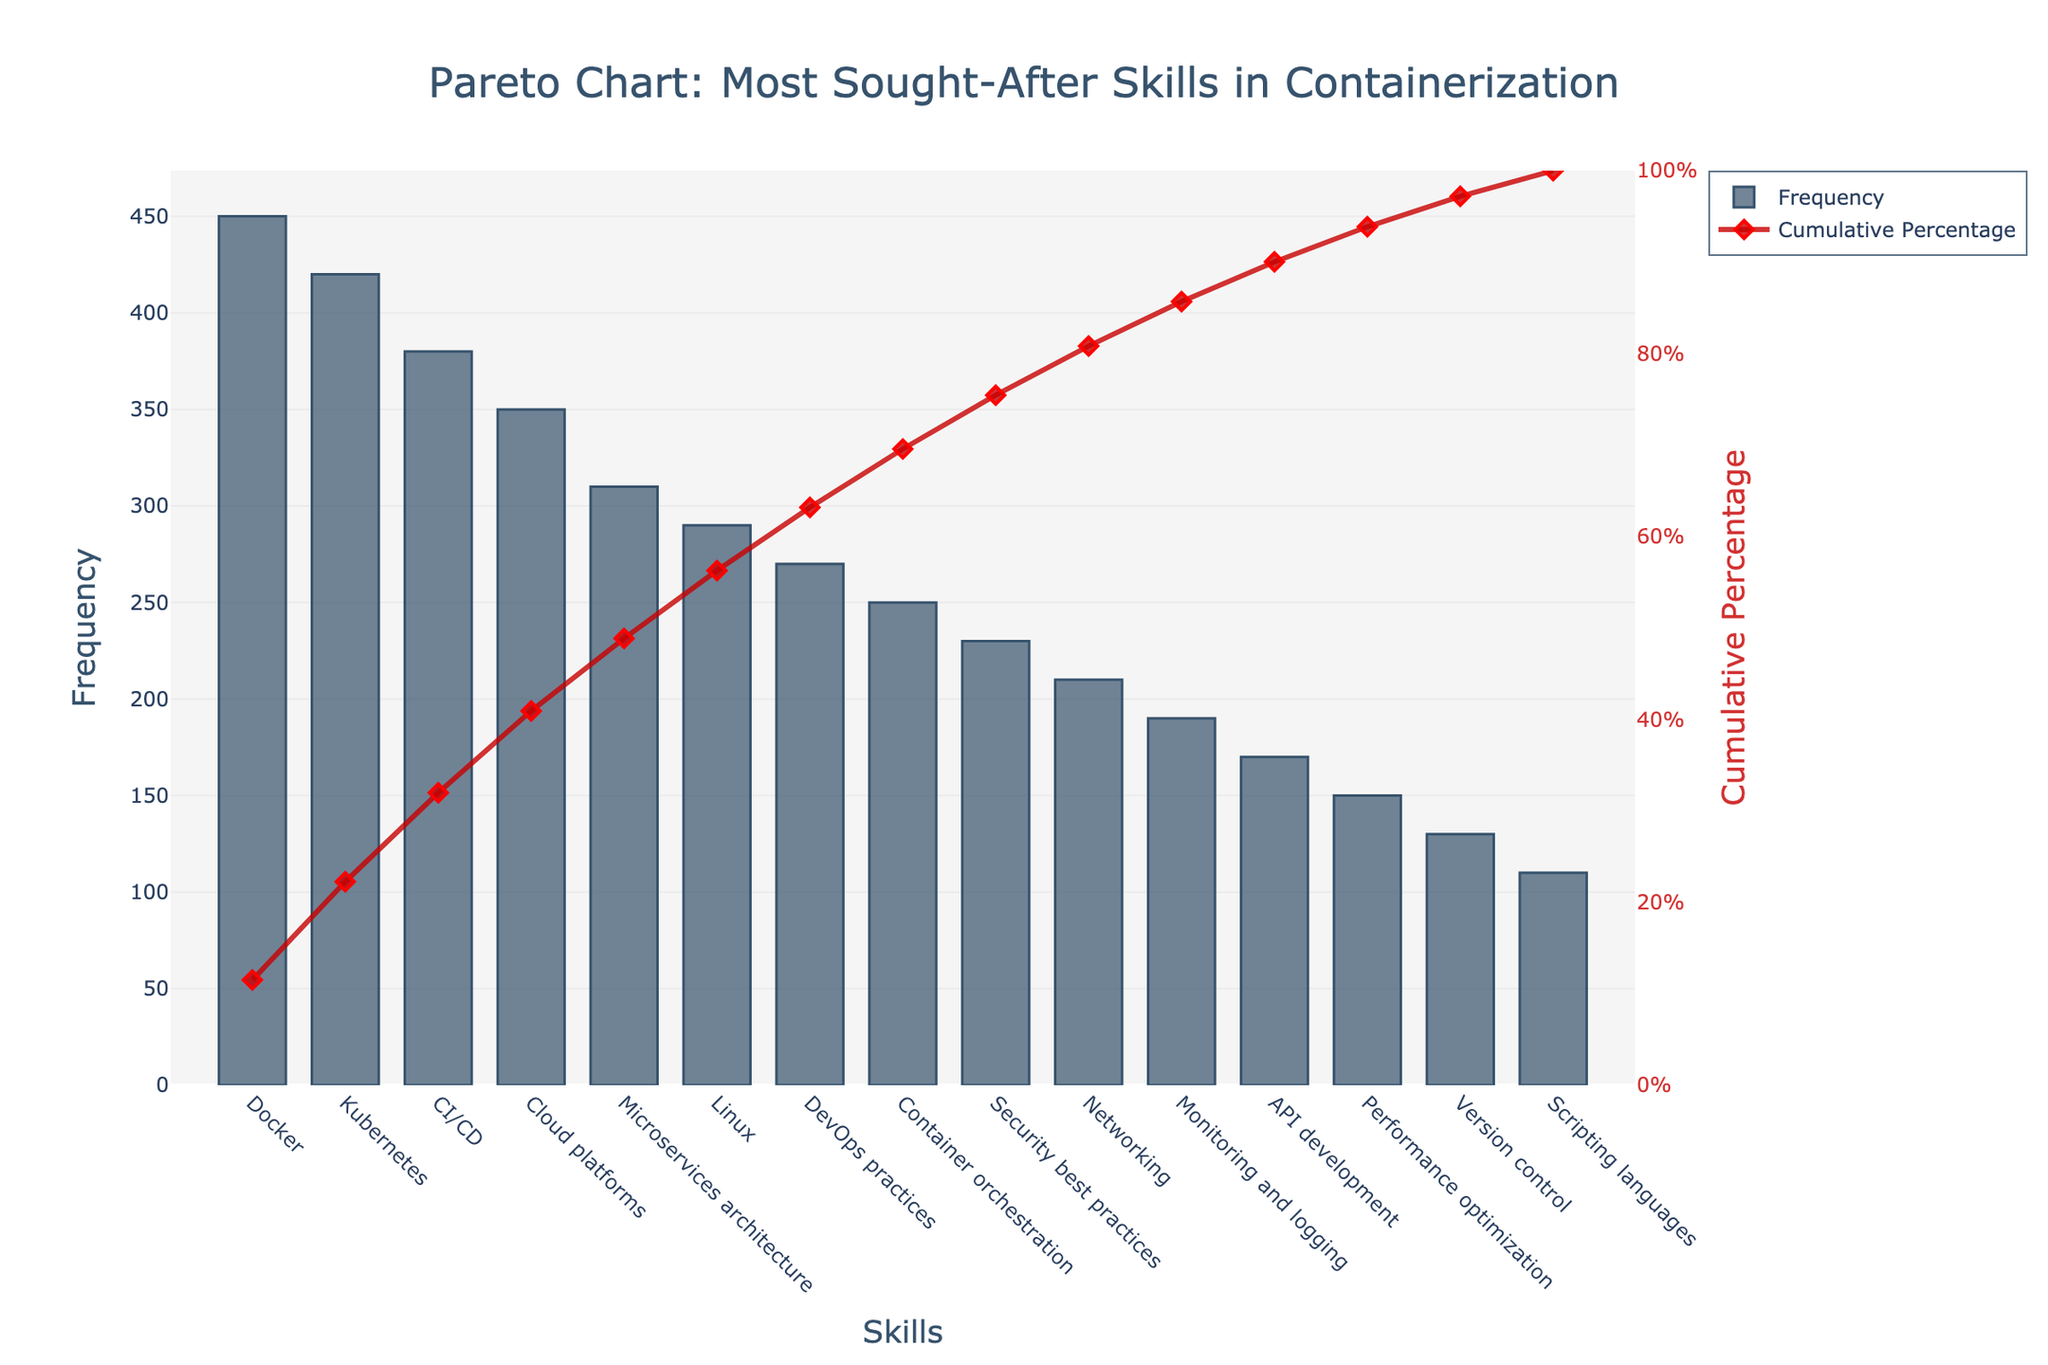What is the skill with the highest demand in the job postings? Looking at the Pareto chart, the skill with the highest frequency bar is at the leftmost of the chart. Its label is "Docker".
Answer: Docker What is the cumulative percentage for Kubernetes? On the Pareto chart, the cumulative percentage line intersects with the Kubernetes bar, which corresponds to a point slightly lower than 40%.
Answer: Slightly lower than 40% How many skills have a frequency over 300? Observing the bars in the Pareto chart, the skills above 300 frequency are Docker, Kubernetes, CI/CD, and Cloud platforms. There are four such skills.
Answer: 4 Which skill has the lowest demand in job postings? The rightmost bar in the Pareto chart has the label "Scripting languages" with the lowest bar height, indicating it's the skill with the lowest demand.
Answer: Scripting languages How many skills make up approximately 80% of the cumulative percentage? Follow the cumulative percentage line until it reaches close to 80%, which touches at the "CI/CD" skill as the last contributing skill. Counting from Docker to CI/CD, there are four skills.
Answer: 4 What is the combined frequency of Cloud platforms and Microservices architecture? The frequency for Cloud platforms is 350 and for Microservices architecture is 310. Adding these together, 350 + 310 = 660.
Answer: 660 What is the difference in demand between DevOps practices and Security best practices? The frequency for DevOps practices is 270 and for Security best practices is 230. Their difference is 270 - 230 = 40.
Answer: 40 Which skill contributes to crossing the 50% cumulative percentage mark? The cumulative percentage line passes the 50% mark at CI/CD because when added together with Docker and Kubernetes, they surpass 50%.
Answer: CI/CD How does the frequency of Networking compare to Monitoring and logging? Looking at the height of the bars, Networking has a higher bar than Monitoring and logging. Networking frequency is 210, and Monitoring and logging frequency is 190.
Answer: Networking is higher What proportion of the total frequency are the top three skills combined? Summing the frequencies of Docker (450), Kubernetes (420), and CI/CD (380), we get 1250. Dividing this by the total sum of all frequencies (450+420+380+350+310+290+270+250+230+210+190+170+150+130+110 = 4410), we get 1250/4410 ≈ 0.283, which is around 28.3%.
Answer: 28.3% 